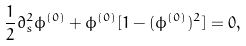<formula> <loc_0><loc_0><loc_500><loc_500>\frac { 1 } { 2 } \partial _ { s } ^ { 2 } \phi ^ { ( 0 ) } + \phi ^ { ( 0 ) } [ 1 - ( \phi ^ { ( 0 ) } ) ^ { 2 } ] = 0 ,</formula> 